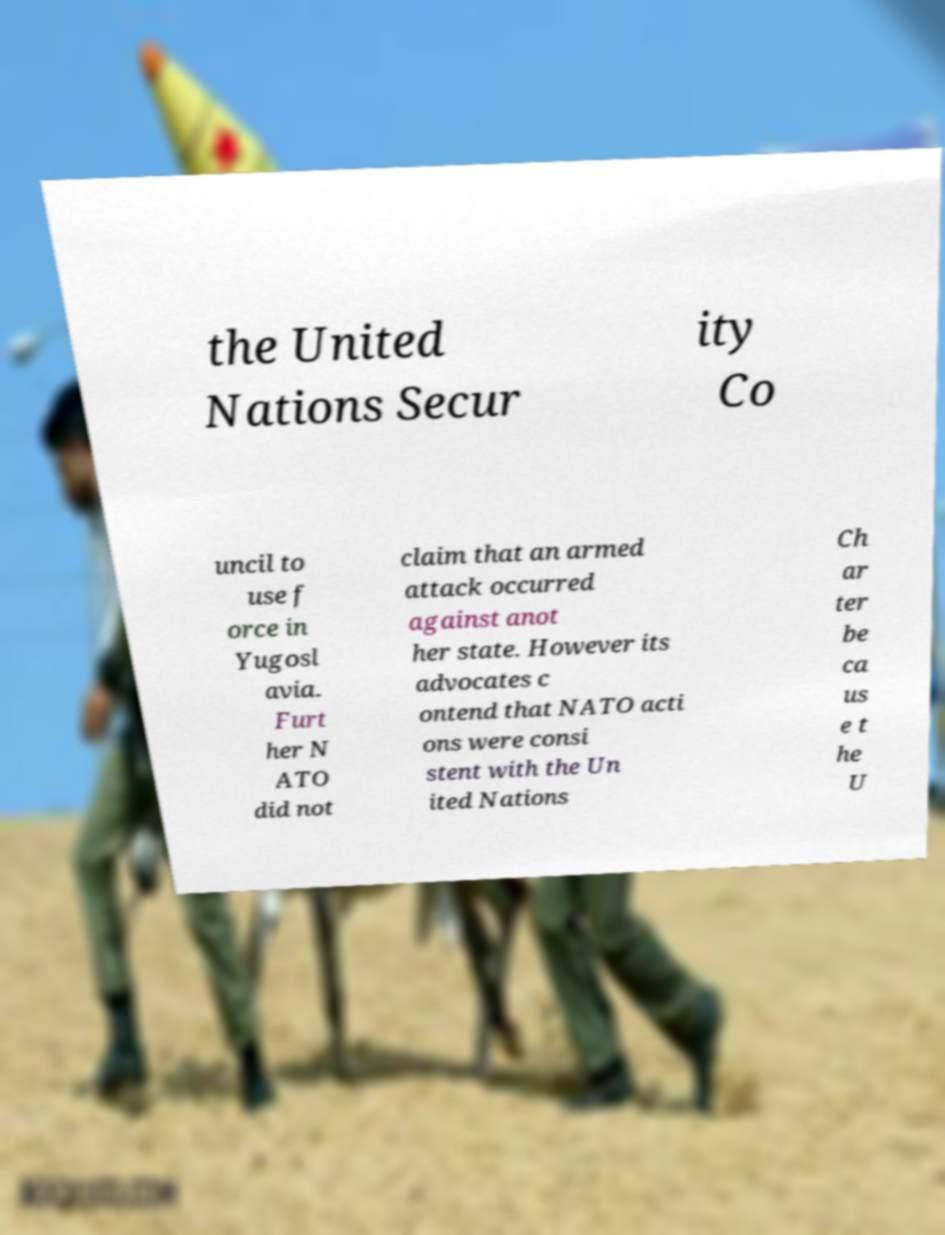For documentation purposes, I need the text within this image transcribed. Could you provide that? the United Nations Secur ity Co uncil to use f orce in Yugosl avia. Furt her N ATO did not claim that an armed attack occurred against anot her state. However its advocates c ontend that NATO acti ons were consi stent with the Un ited Nations Ch ar ter be ca us e t he U 